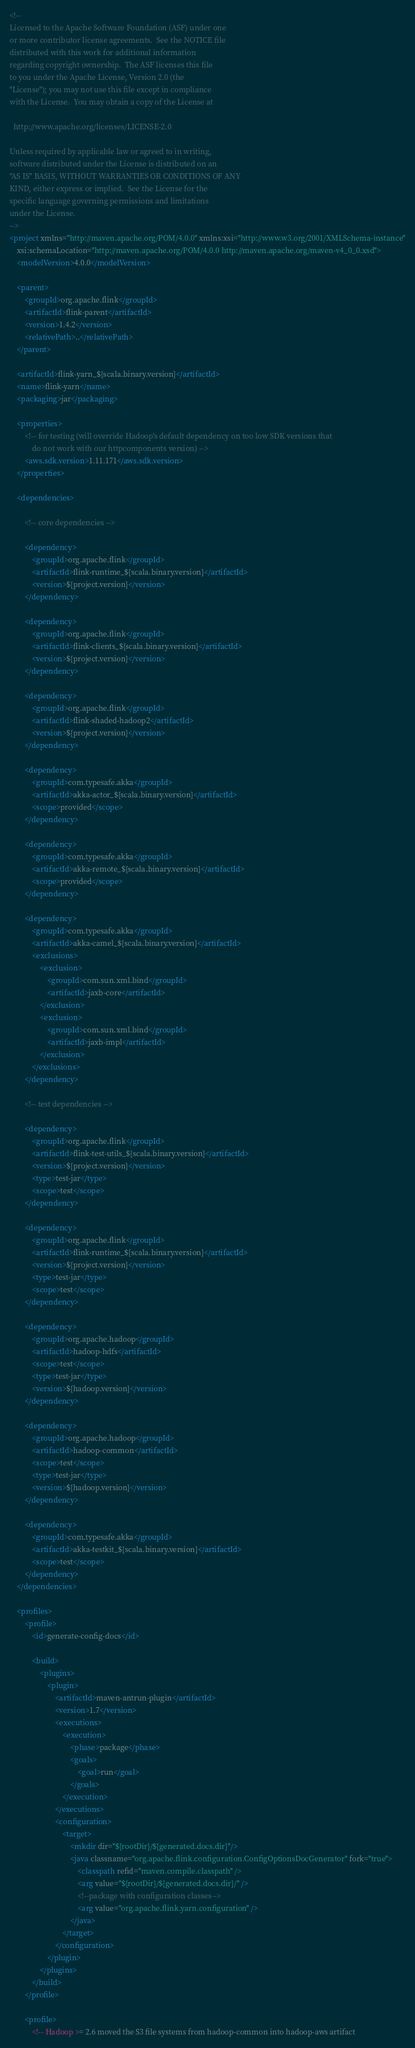<code> <loc_0><loc_0><loc_500><loc_500><_XML_><!--
Licensed to the Apache Software Foundation (ASF) under one
or more contributor license agreements.  See the NOTICE file
distributed with this work for additional information
regarding copyright ownership.  The ASF licenses this file
to you under the Apache License, Version 2.0 (the
"License"); you may not use this file except in compliance
with the License.  You may obtain a copy of the License at

  http://www.apache.org/licenses/LICENSE-2.0

Unless required by applicable law or agreed to in writing,
software distributed under the License is distributed on an
"AS IS" BASIS, WITHOUT WARRANTIES OR CONDITIONS OF ANY
KIND, either express or implied.  See the License for the
specific language governing permissions and limitations
under the License.
-->
<project xmlns="http://maven.apache.org/POM/4.0.0" xmlns:xsi="http://www.w3.org/2001/XMLSchema-instance"
	xsi:schemaLocation="http://maven.apache.org/POM/4.0.0 http://maven.apache.org/maven-v4_0_0.xsd">
	<modelVersion>4.0.0</modelVersion>

	<parent>
		<groupId>org.apache.flink</groupId>
		<artifactId>flink-parent</artifactId>
		<version>1.4.2</version>
		<relativePath>..</relativePath>
	</parent>

	<artifactId>flink-yarn_${scala.binary.version}</artifactId>
	<name>flink-yarn</name>
	<packaging>jar</packaging>

	<properties>
		<!-- for testing (will override Hadoop's default dependency on too low SDK versions that
			do not work with our httpcomponents version) -->
		<aws.sdk.version>1.11.171</aws.sdk.version>
	</properties>

	<dependencies>

		<!-- core dependencies -->

		<dependency>
			<groupId>org.apache.flink</groupId>
			<artifactId>flink-runtime_${scala.binary.version}</artifactId>
			<version>${project.version}</version>
		</dependency>

		<dependency>
			<groupId>org.apache.flink</groupId>
			<artifactId>flink-clients_${scala.binary.version}</artifactId>
			<version>${project.version}</version>
		</dependency>

		<dependency>
			<groupId>org.apache.flink</groupId>
			<artifactId>flink-shaded-hadoop2</artifactId>
			<version>${project.version}</version>
		</dependency>

		<dependency>
			<groupId>com.typesafe.akka</groupId>
			<artifactId>akka-actor_${scala.binary.version}</artifactId>
			<scope>provided</scope>
		</dependency>

		<dependency>
			<groupId>com.typesafe.akka</groupId>
			<artifactId>akka-remote_${scala.binary.version}</artifactId>
			<scope>provided</scope>
		</dependency>

		<dependency>
			<groupId>com.typesafe.akka</groupId>
			<artifactId>akka-camel_${scala.binary.version}</artifactId>
			<exclusions>
				<exclusion>
					<groupId>com.sun.xml.bind</groupId>
					<artifactId>jaxb-core</artifactId>
				</exclusion>
				<exclusion>
					<groupId>com.sun.xml.bind</groupId>
					<artifactId>jaxb-impl</artifactId>
				</exclusion>
			</exclusions>
		</dependency>

		<!-- test dependencies -->

		<dependency>
			<groupId>org.apache.flink</groupId>
			<artifactId>flink-test-utils_${scala.binary.version}</artifactId>
			<version>${project.version}</version>
			<type>test-jar</type>
			<scope>test</scope>
		</dependency>

		<dependency>
			<groupId>org.apache.flink</groupId>
			<artifactId>flink-runtime_${scala.binary.version}</artifactId>
			<version>${project.version}</version>
			<type>test-jar</type>
			<scope>test</scope>
		</dependency>

		<dependency>
			<groupId>org.apache.hadoop</groupId>
			<artifactId>hadoop-hdfs</artifactId>
			<scope>test</scope>
			<type>test-jar</type>
			<version>${hadoop.version}</version>
		</dependency>

		<dependency>
			<groupId>org.apache.hadoop</groupId>
			<artifactId>hadoop-common</artifactId>
			<scope>test</scope>
			<type>test-jar</type>
			<version>${hadoop.version}</version>
		</dependency>

		<dependency>
			<groupId>com.typesafe.akka</groupId>
			<artifactId>akka-testkit_${scala.binary.version}</artifactId>
			<scope>test</scope>
		</dependency>
	</dependencies>

	<profiles>
		<profile>
			<id>generate-config-docs</id>

			<build>
				<plugins>
					<plugin>
						<artifactId>maven-antrun-plugin</artifactId>
						<version>1.7</version>
						<executions>
							<execution>
								<phase>package</phase>
								<goals>
									<goal>run</goal>
								</goals>
							</execution>
						</executions>
						<configuration>
							<target>
								<mkdir dir="${rootDir}/${generated.docs.dir}"/>
								<java classname="org.apache.flink.configuration.ConfigOptionsDocGenerator" fork="true">
									<classpath refid="maven.compile.classpath" />
									<arg value="${rootDir}/${generated.docs.dir}/" />
									<!--package with configuration classes-->
									<arg value="org.apache.flink.yarn.configuration" />
								</java>
							</target>
						</configuration>
					</plugin>
				</plugins>
			</build>
		</profile>

		<profile>
			<!-- Hadoop >= 2.6 moved the S3 file systems from hadoop-common into hadoop-aws artifact</code> 